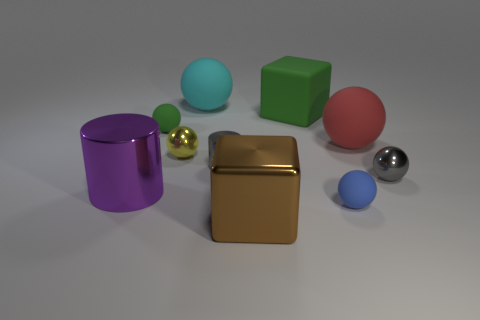Subtract all tiny blue matte balls. How many balls are left? 5 Subtract all red balls. How many balls are left? 5 Subtract 4 balls. How many balls are left? 2 Subtract all brown balls. Subtract all blue cylinders. How many balls are left? 6 Subtract all balls. How many objects are left? 4 Add 2 tiny cyan cylinders. How many tiny cyan cylinders exist? 2 Subtract 0 purple blocks. How many objects are left? 10 Subtract all blue balls. Subtract all purple metallic objects. How many objects are left? 8 Add 8 green spheres. How many green spheres are left? 9 